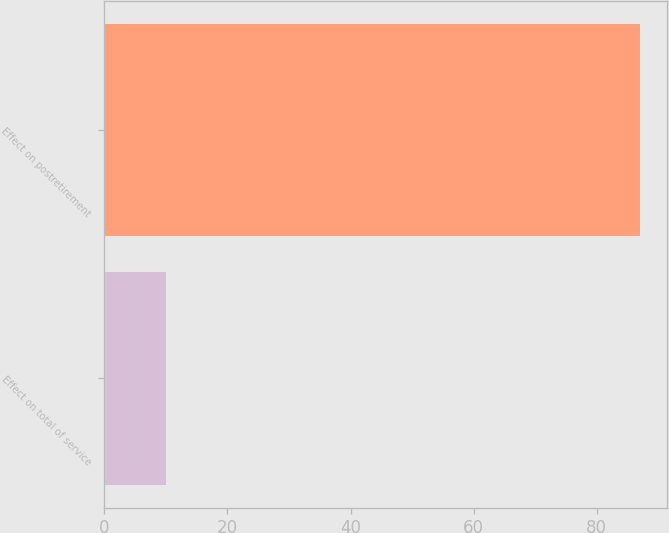Convert chart to OTSL. <chart><loc_0><loc_0><loc_500><loc_500><bar_chart><fcel>Effect on total of service<fcel>Effect on postretirement<nl><fcel>10<fcel>87<nl></chart> 